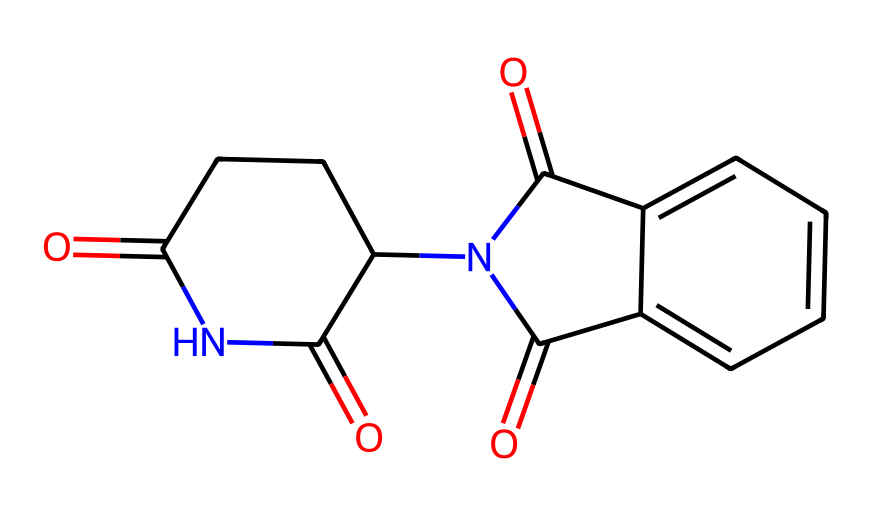What is the molecular formula of thalidomide? To find the molecular formula, count the numbers of each type of atom in the chemical structure. The structure contains 13 carbon (C) atoms, 11 hydrogen (H) atoms, 3 nitrogen (N) atoms, and 4 oxygen (O) atoms, resulting in the molecular formula C13H11N2O4.
Answer: C13H11N2O4 How many rings are present in the structure of thalidomide? Analyzing the chemical structure, there are two distinct ring systems; one is a five-membered ring and the other is a six-membered ring. Thus, the total count of rings is two.
Answer: 2 Identify the functional groups present in thalidomide. The structure shows the presence of amide groups (-C(=O)N-), carbonyl groups (C=O), and a cyclic structure with connections suggesting multiple functional groups. The amide and carbonyl functions are noted.
Answer: amide, carbonyl Does thalidomide exhibit chirality? To determine chirality, assess the presence of chiral centers in the structure. Thalidomide contains at least one carbon atom bonded to four different substituents, indicating that the compound is chiral.
Answer: yes What is the importance of thalidomide in the context of drug regulation? Thalidomide's introduction and subsequent effects highlighted the need for stringent drug safety assessments due to its teratogenic effects, leading to tighter regulations in drug approval processes.
Answer: historical regulation How many nitrogen atoms are in thalidomide? Inspecting the chemical structure reveals two nitrogen atoms (N) marked within the molecule, thus the count is two.
Answer: 2 What is the primary use of thalidomide today? Currently, thalidomide is primarily used to treat certain conditions such as multiple myeloma and leprosy-related complications, reflecting its therapeutic applications.
Answer: multiple myeloma 